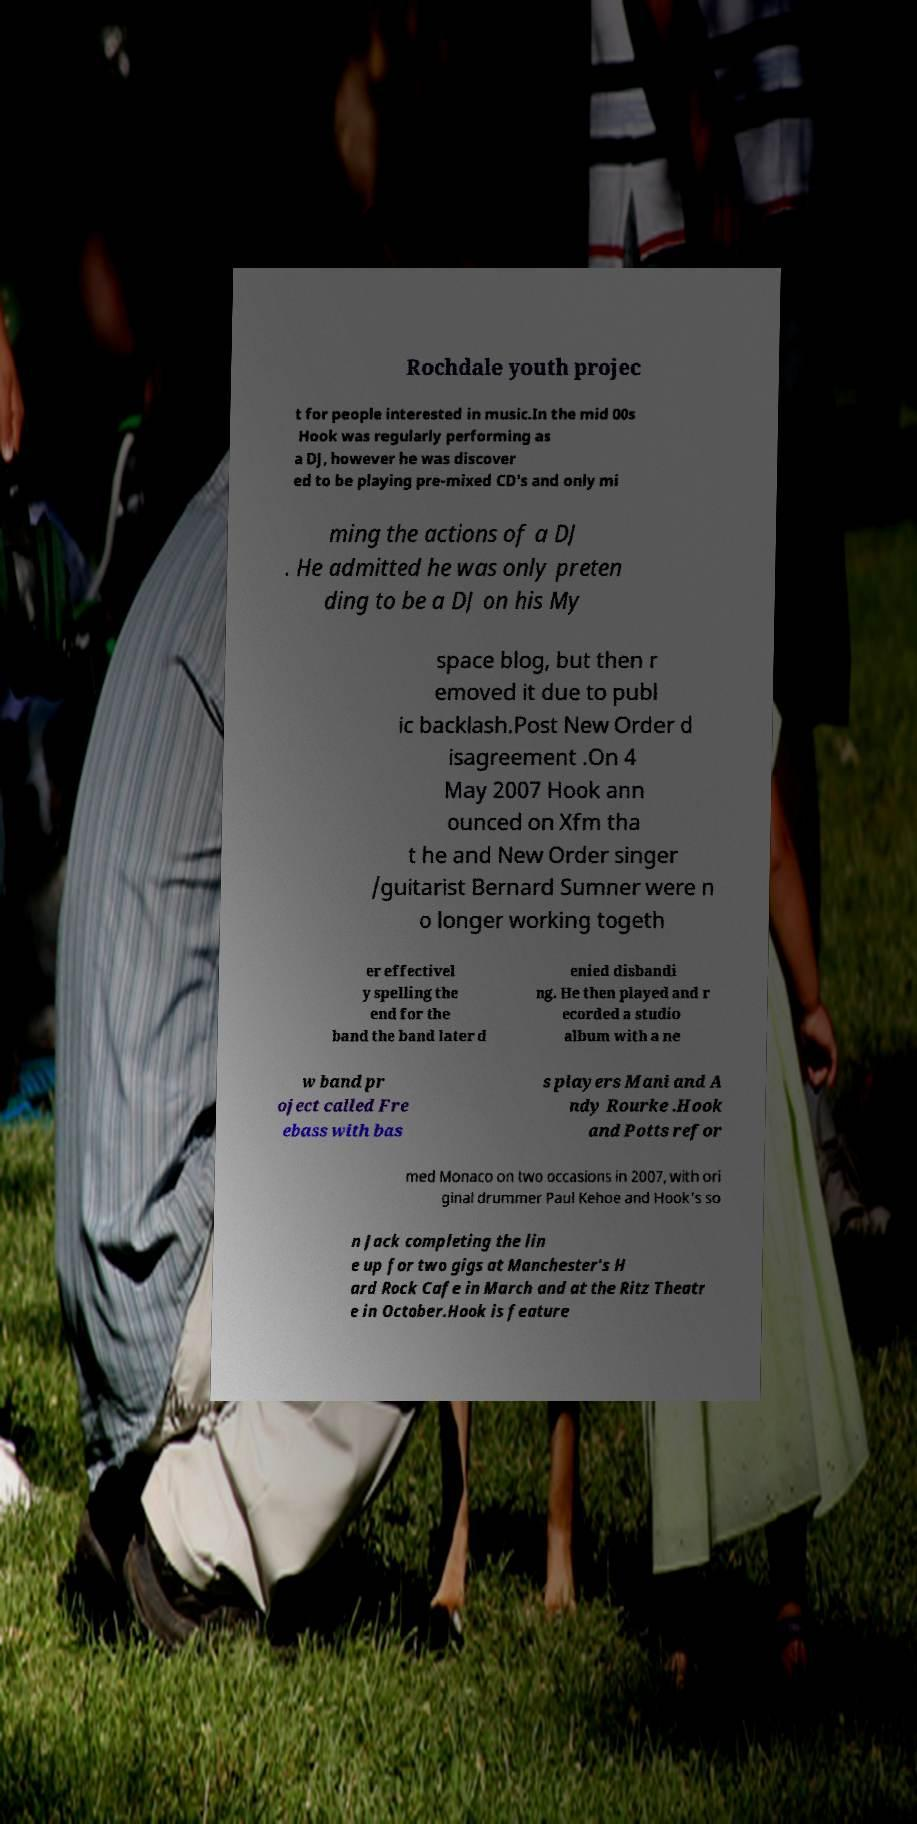Could you assist in decoding the text presented in this image and type it out clearly? Rochdale youth projec t for people interested in music.In the mid 00s Hook was regularly performing as a DJ, however he was discover ed to be playing pre-mixed CD's and only mi ming the actions of a DJ . He admitted he was only preten ding to be a DJ on his My space blog, but then r emoved it due to publ ic backlash.Post New Order d isagreement .On 4 May 2007 Hook ann ounced on Xfm tha t he and New Order singer /guitarist Bernard Sumner were n o longer working togeth er effectivel y spelling the end for the band the band later d enied disbandi ng. He then played and r ecorded a studio album with a ne w band pr oject called Fre ebass with bas s players Mani and A ndy Rourke .Hook and Potts refor med Monaco on two occasions in 2007, with ori ginal drummer Paul Kehoe and Hook's so n Jack completing the lin e up for two gigs at Manchester's H ard Rock Cafe in March and at the Ritz Theatr e in October.Hook is feature 